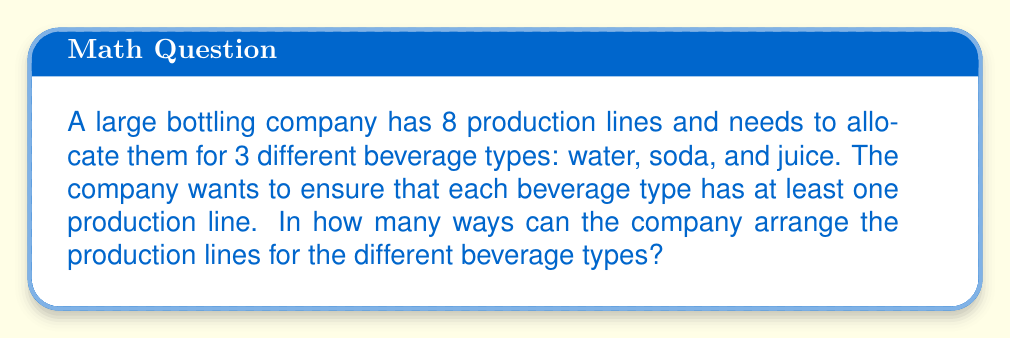Help me with this question. Let's approach this step-by-step:

1) This is a problem of distributing distinct objects (production lines) into distinct groups (beverage types) with restrictions.

2) We can use the concept of stirling numbers of the second kind and multiply by the number of ways to permute the groups.

3) Let $S(n,k)$ represent the Stirling number of the second kind, where $n$ is the number of objects and $k$ is the number of non-empty groups.

4) In this case, we have 8 production lines (n = 8) and 3 beverage types (k = 3).

5) The formula for $S(8,3)$ is:

   $$S(8,3) = \frac{1}{3!}\sum_{i=0}^3 (-1)^i \binom{3}{i}(3-i)^8$$

6) Calculating this:
   $$S(8,3) = \frac{1}{6}[3^8 - 3 \cdot 2^8 + 3 \cdot 1^8] = 966$$

7) However, this counts the number of ways to distribute the lines into 3 unnamed groups. We need to multiply by 3! to account for the different ways these groups can be assigned to water, soda, and juice.

8) Therefore, the final answer is:

   $$966 \cdot 3! = 966 \cdot 6 = 5,796$$
Answer: 5,796 